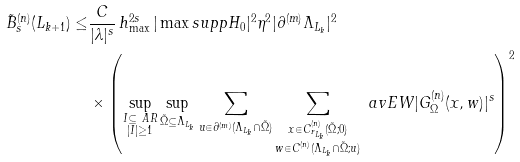<formula> <loc_0><loc_0><loc_500><loc_500>\tilde { B } _ { s } ^ { ( n ) } ( L _ { k + 1 } ) \leq & \frac { C } { | \lambda | ^ { s } } \, h _ { \max } ^ { 2 s } \, | \max s u p p H _ { 0 } | ^ { 2 } \eta ^ { 2 } | \partial ^ { ( m ) } \Lambda _ { L _ { k } } | ^ { 2 } \\ & \times \left ( \sup _ { \substack { I \subseteq \ A R \\ | I | \geq 1 } } \sup _ { \tilde { \Omega } \subseteq \Lambda _ { L _ { k } } } \sum _ { u \in \partial ^ { ( m ) } ( \Lambda _ { L _ { k } } \cap \tilde { \Omega } ) } \sum _ { \substack { x \in C ^ { ( n ) } _ { r _ { L _ { k } } } ( \tilde { \Omega } ; 0 ) \\ w \in C ^ { ( n ) } ( \Lambda _ { L _ { k } } \cap \tilde { \Omega } ; u ) } } \ a v E W { | G ^ { ( n ) } _ { \Omega } ( x , w ) | ^ { s } } \right ) ^ { 2 }</formula> 